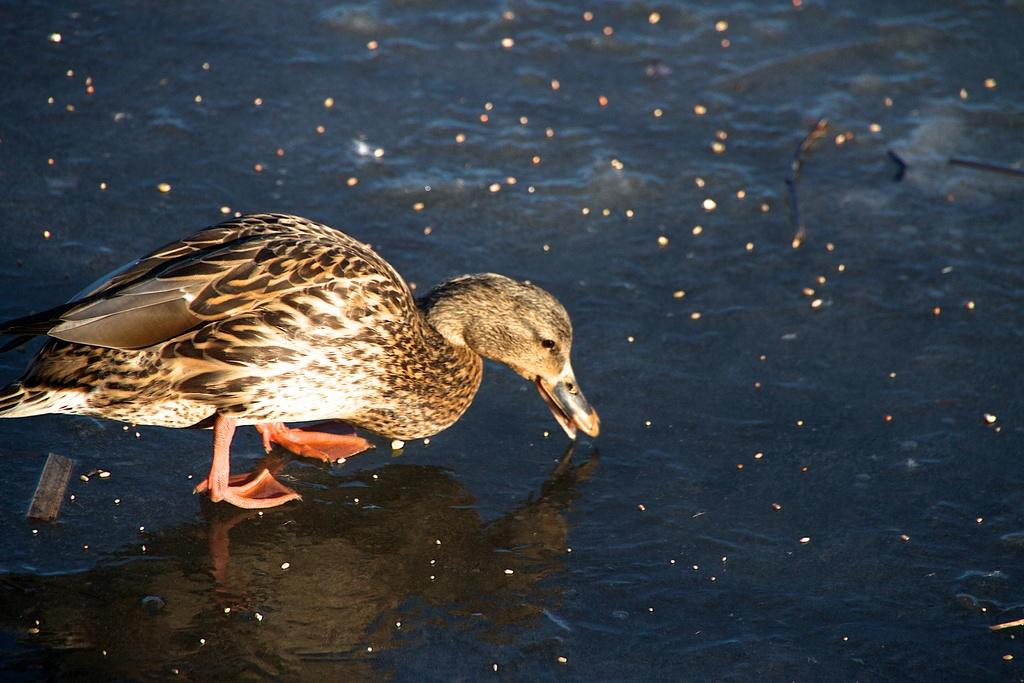What type of animal is in the image? There is a brown duck in the image. What is the duck standing on? The duck is standing on a frozen water surface. What type of legal advice can the duck provide in the image? The duck is not a legal expert and cannot provide any legal advice in the image. 